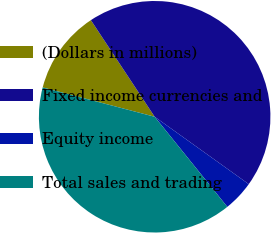Convert chart to OTSL. <chart><loc_0><loc_0><loc_500><loc_500><pie_chart><fcel>(Dollars in millions)<fcel>Fixed income currencies and<fcel>Equity income<fcel>Total sales and trading<nl><fcel>11.64%<fcel>44.18%<fcel>4.31%<fcel>39.88%<nl></chart> 